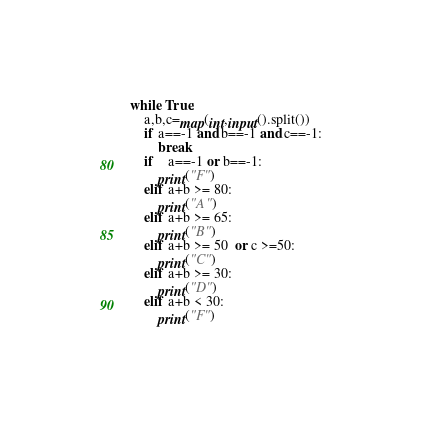Convert code to text. <code><loc_0><loc_0><loc_500><loc_500><_Python_>while True:	
	a,b,c=map(int,input().split())
	if a==-1 and b==-1 and c==-1:
		break
	if	a==-1 or b==-1:
		print("F")
	elif a+b >= 80:
		print("A")
	elif a+b >= 65:
		print("B")
	elif a+b >= 50  or c >=50:
		print("C")
	elif a+b >= 30:
		print("D")
	elif a+b < 30:
		print("F")

</code> 